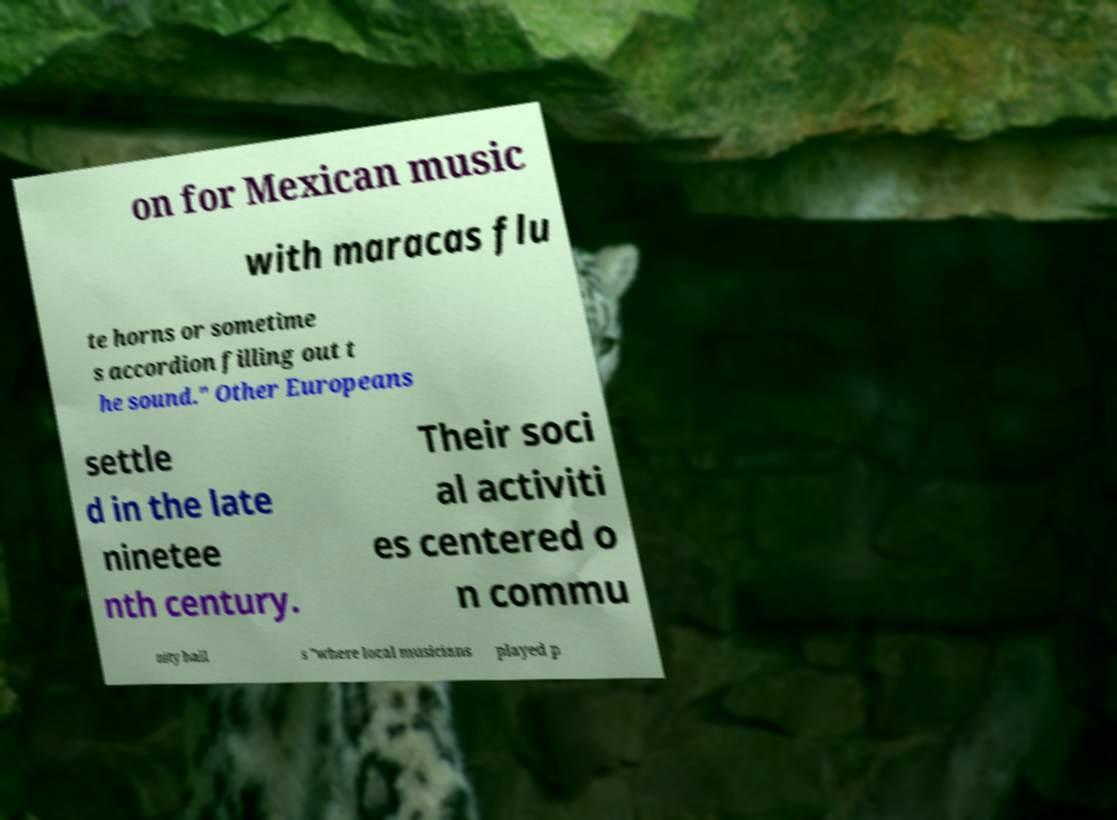Can you read and provide the text displayed in the image?This photo seems to have some interesting text. Can you extract and type it out for me? on for Mexican music with maracas flu te horns or sometime s accordion filling out t he sound." Other Europeans settle d in the late ninetee nth century. Their soci al activiti es centered o n commu nity hall s "where local musicians played p 